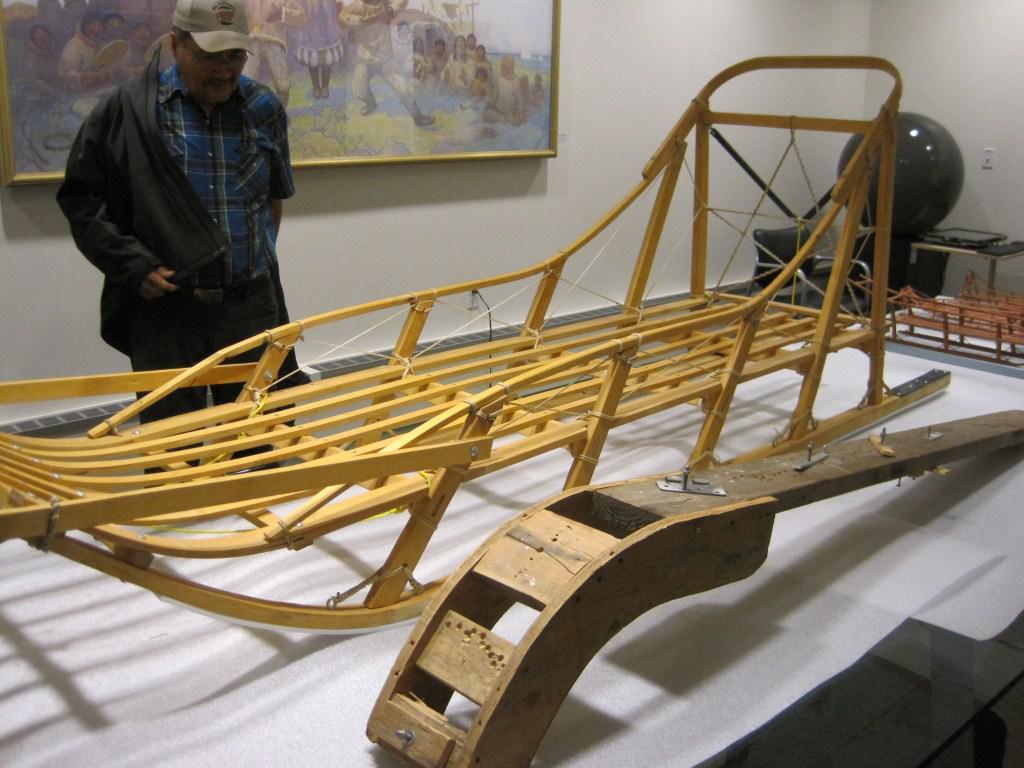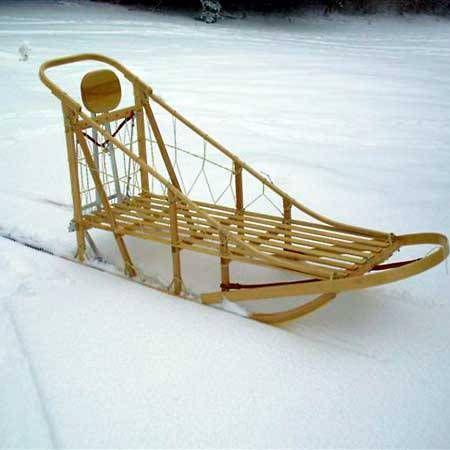The first image is the image on the left, the second image is the image on the right. For the images shown, is this caption "The left image contains exactly one male human." true? Answer yes or no. Yes. The first image is the image on the left, the second image is the image on the right. For the images displayed, is the sentence "There is a human looking at a sled in one of the images." factually correct? Answer yes or no. Yes. 